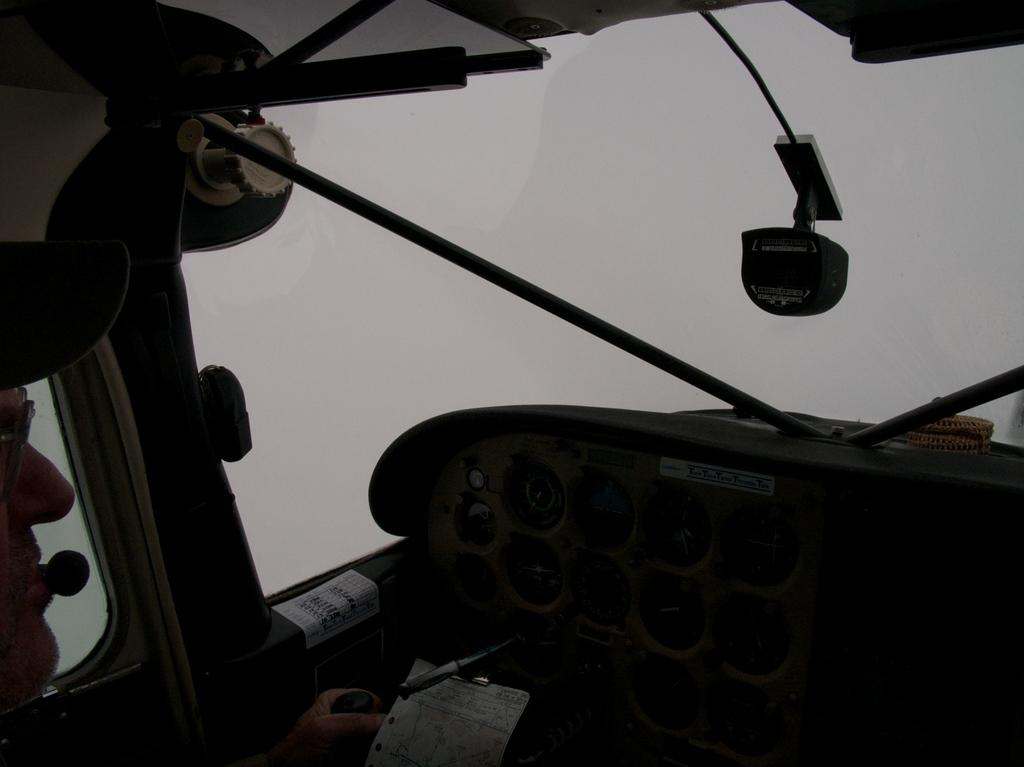What is the setting of the image? The image shows the inside of a helicopter. What can be found in the front of the helicopter? There is a cluster unit and windshield glass in the front of the helicopter. What type of oil is being used to lubricate the string in the image? There is no string or oil present in the image; it shows the inside of a helicopter with a cluster unit and windshield glass in the front. 